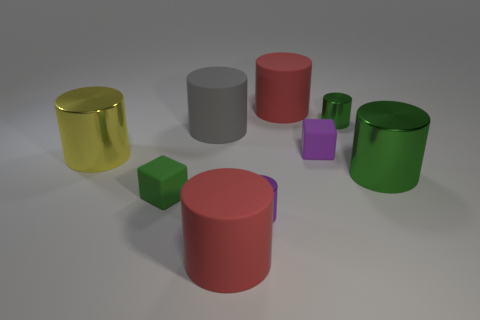How would the scene change if the light source was moved to directly above the purple cube? If the light source were positioned directly above the purple cube, the shadows would be cast differently. All objects would cast shorter shadows directly beneath them, emphasizing their vertical profile and the purple cube would likely have the smallest shadow. The scene would also have a more balanced illumination with fewer elongated shadows stretching across the surface. 